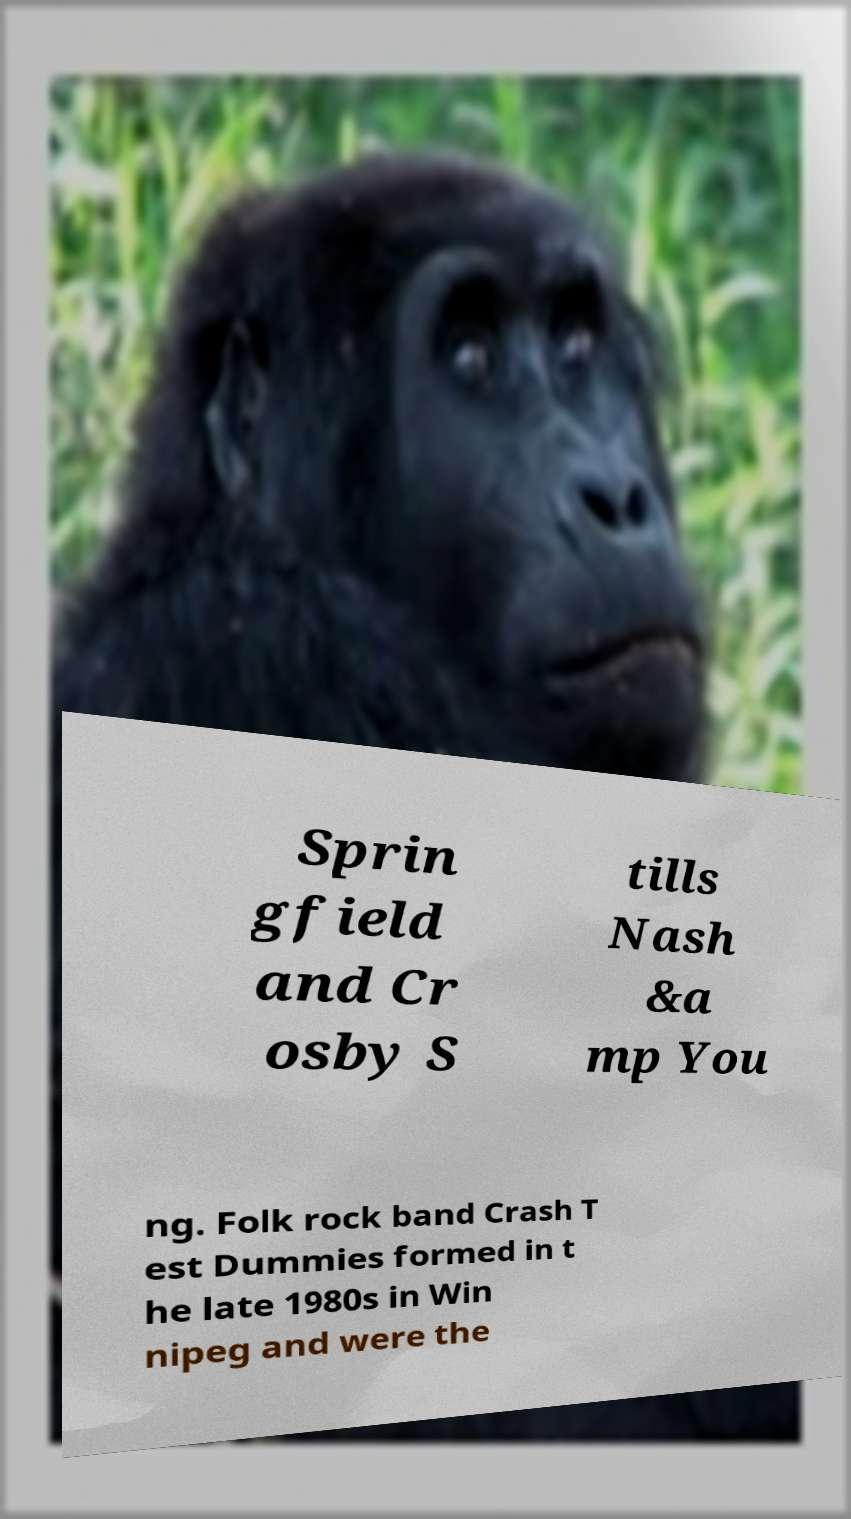For documentation purposes, I need the text within this image transcribed. Could you provide that? Sprin gfield and Cr osby S tills Nash &a mp You ng. Folk rock band Crash T est Dummies formed in t he late 1980s in Win nipeg and were the 